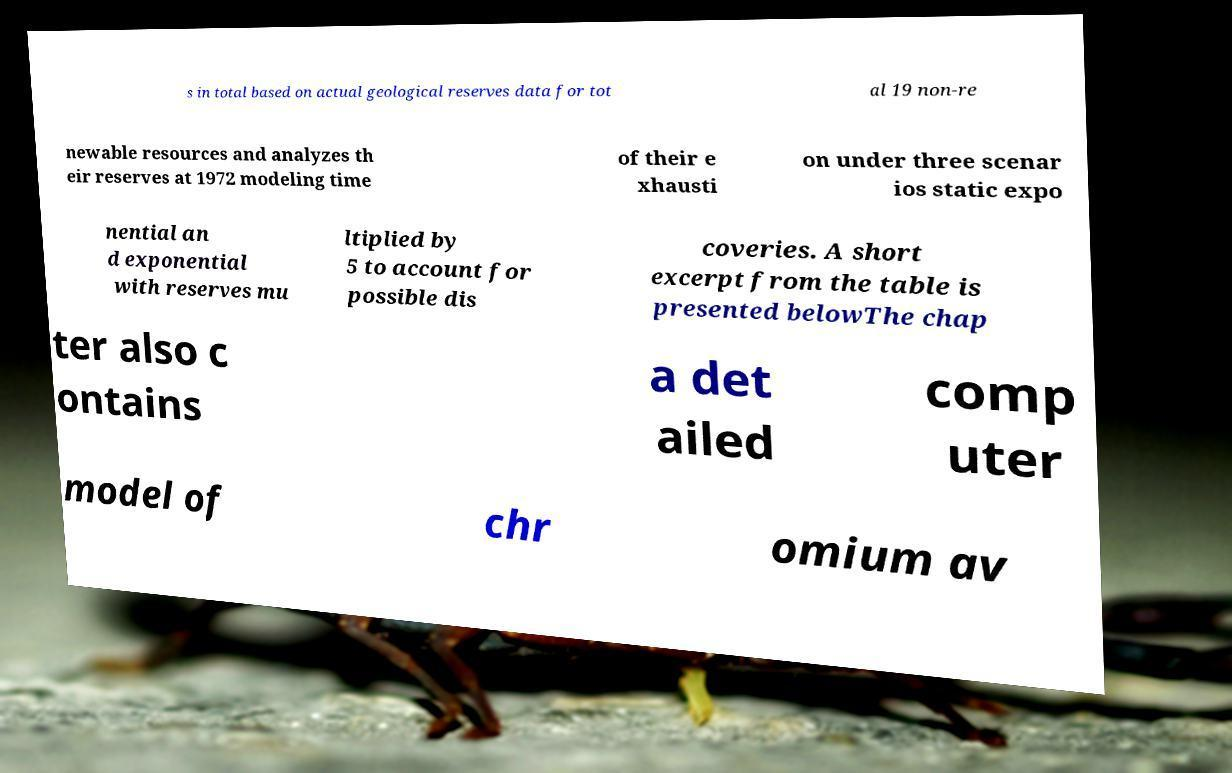Please read and relay the text visible in this image. What does it say? s in total based on actual geological reserves data for tot al 19 non-re newable resources and analyzes th eir reserves at 1972 modeling time of their e xhausti on under three scenar ios static expo nential an d exponential with reserves mu ltiplied by 5 to account for possible dis coveries. A short excerpt from the table is presented belowThe chap ter also c ontains a det ailed comp uter model of chr omium av 